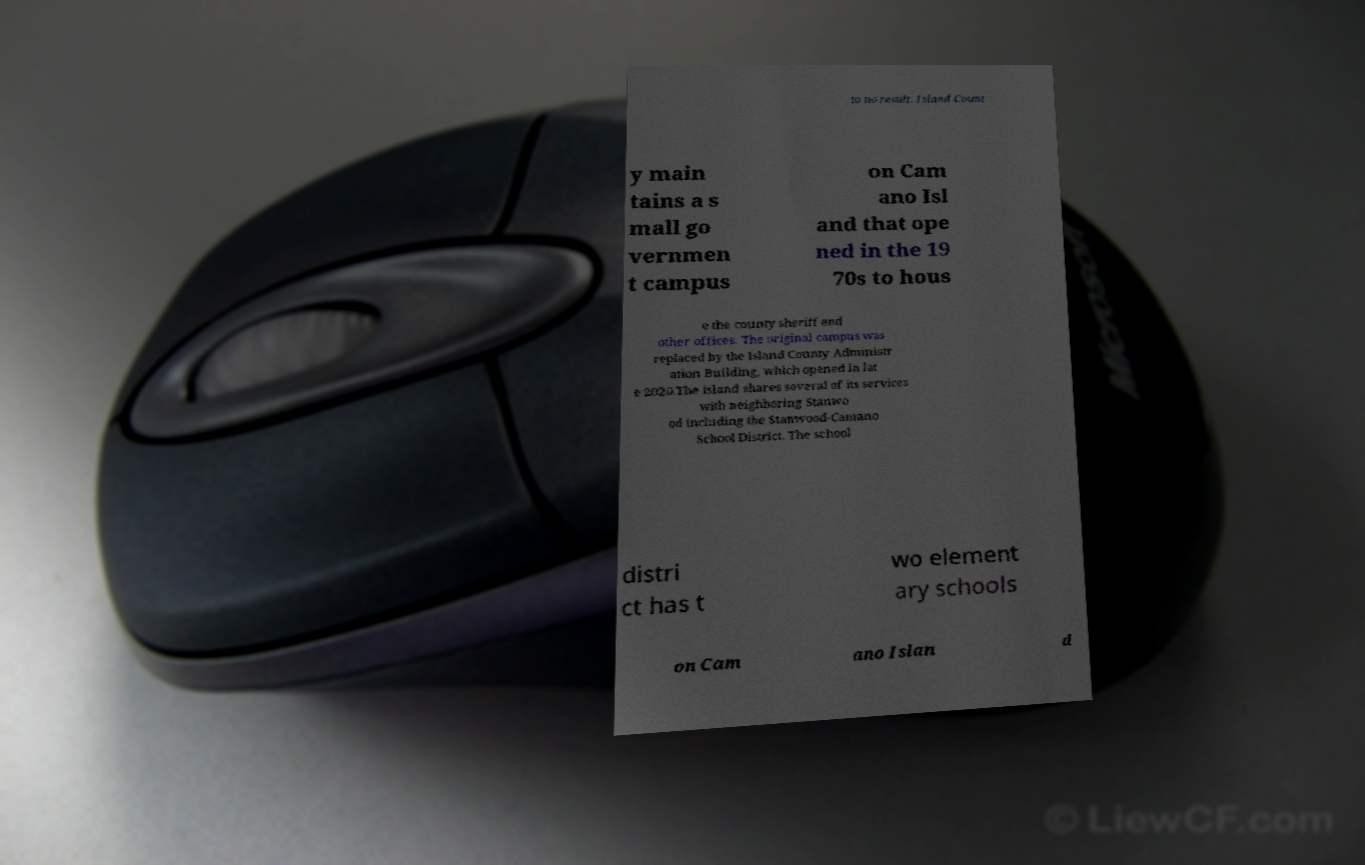Can you accurately transcribe the text from the provided image for me? to no result. Island Count y main tains a s mall go vernmen t campus on Cam ano Isl and that ope ned in the 19 70s to hous e the county sheriff and other offices. The original campus was replaced by the Island County Administr ation Building, which opened in lat e 2020.The island shares several of its services with neighboring Stanwo od including the Stanwood-Camano School District. The school distri ct has t wo element ary schools on Cam ano Islan d 